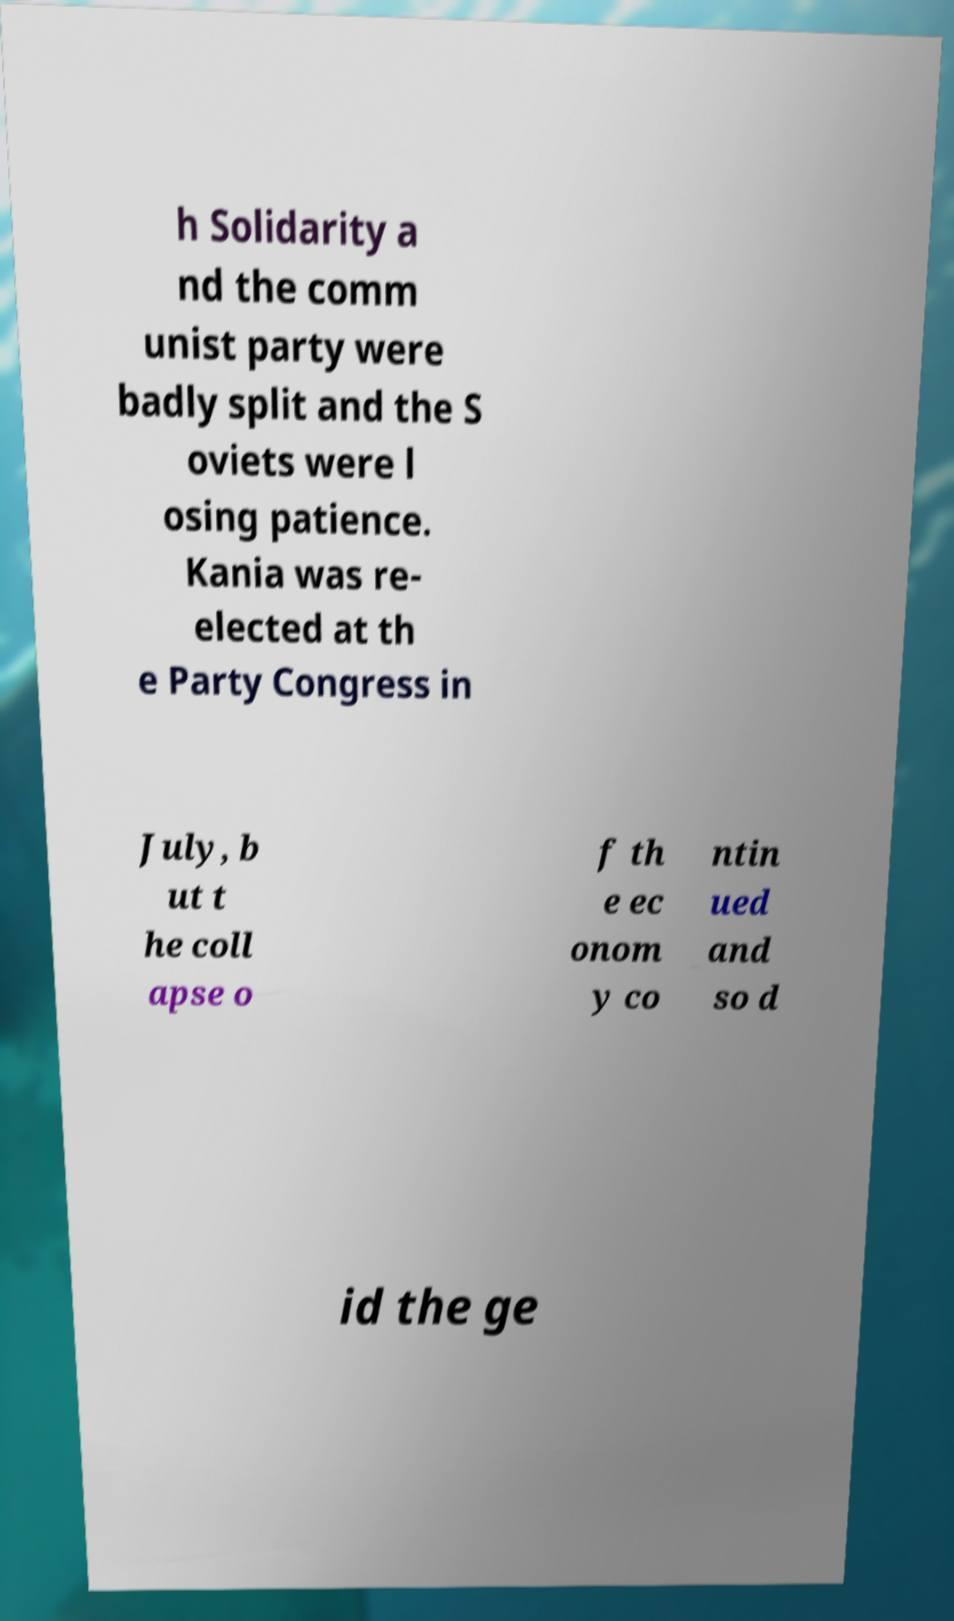Can you accurately transcribe the text from the provided image for me? h Solidarity a nd the comm unist party were badly split and the S oviets were l osing patience. Kania was re- elected at th e Party Congress in July, b ut t he coll apse o f th e ec onom y co ntin ued and so d id the ge 